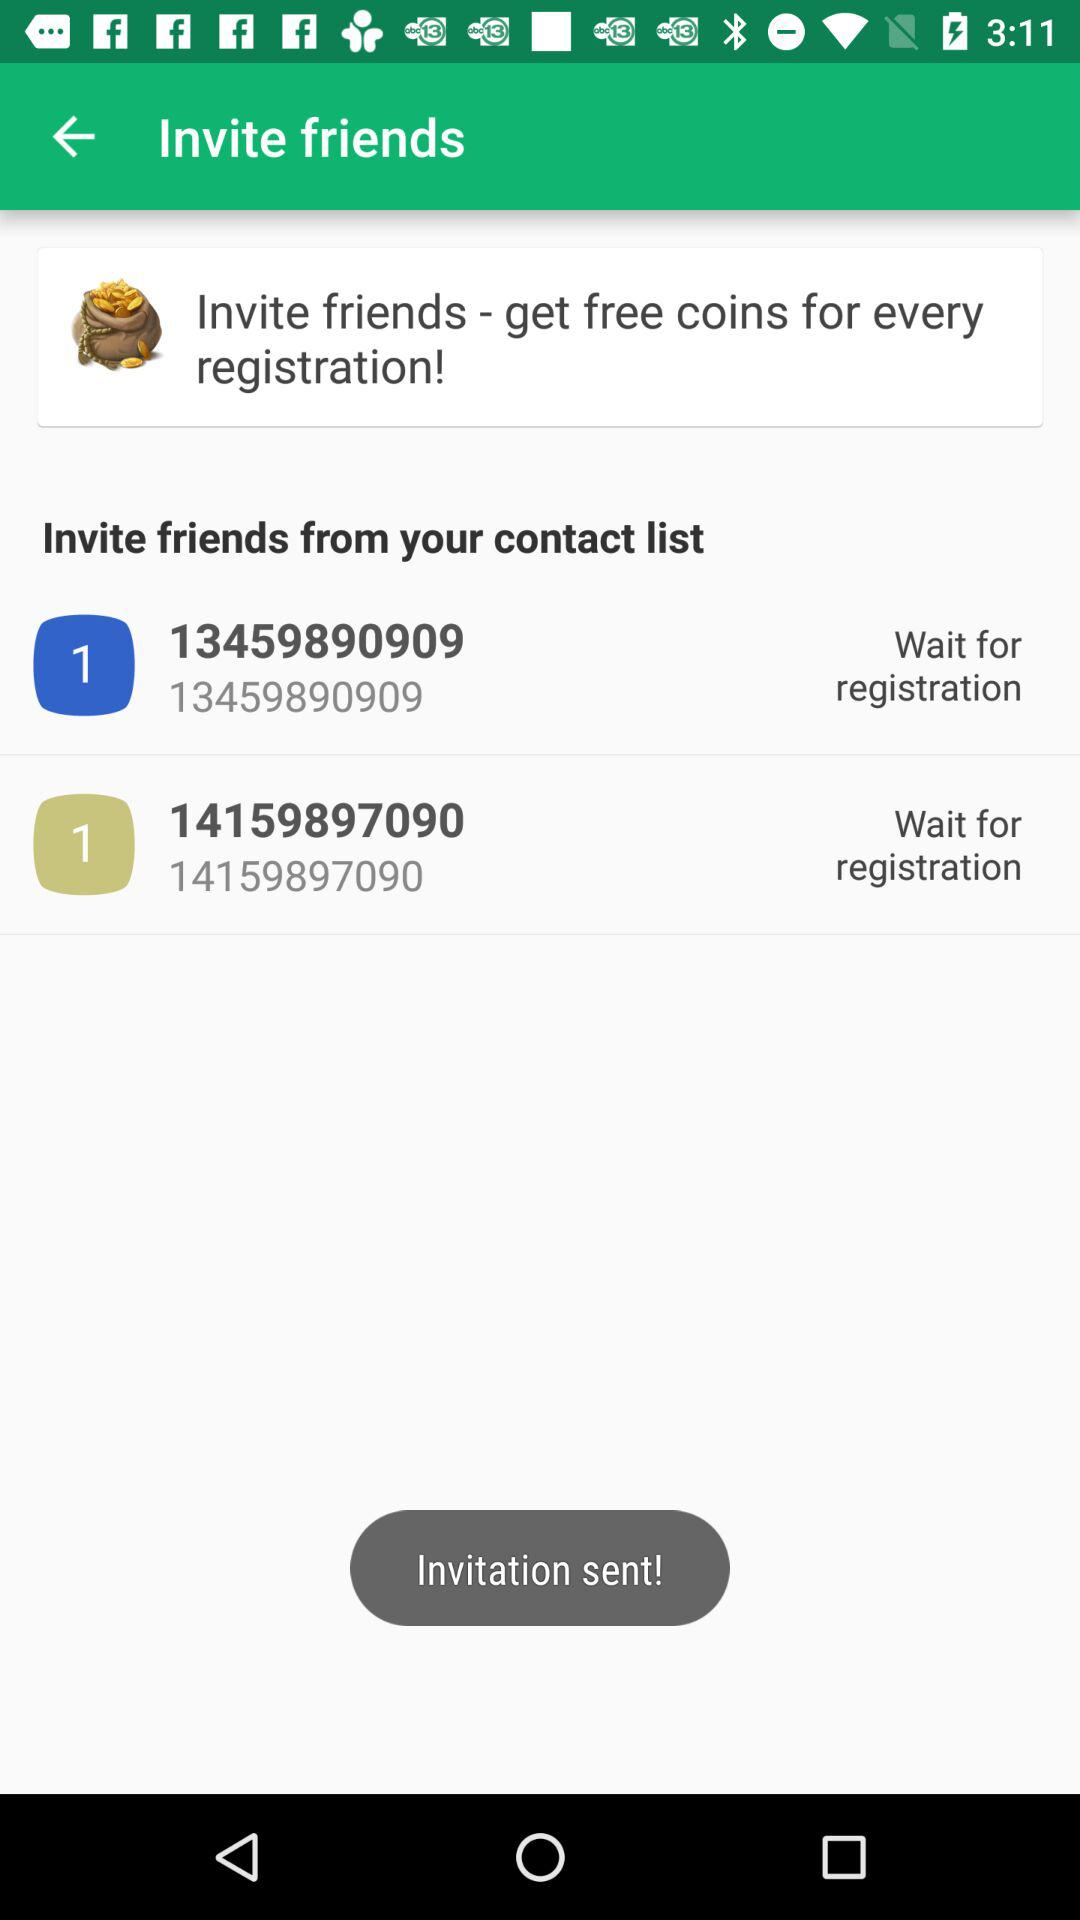How many people have you invited so far?
Answer the question using a single word or phrase. 2 